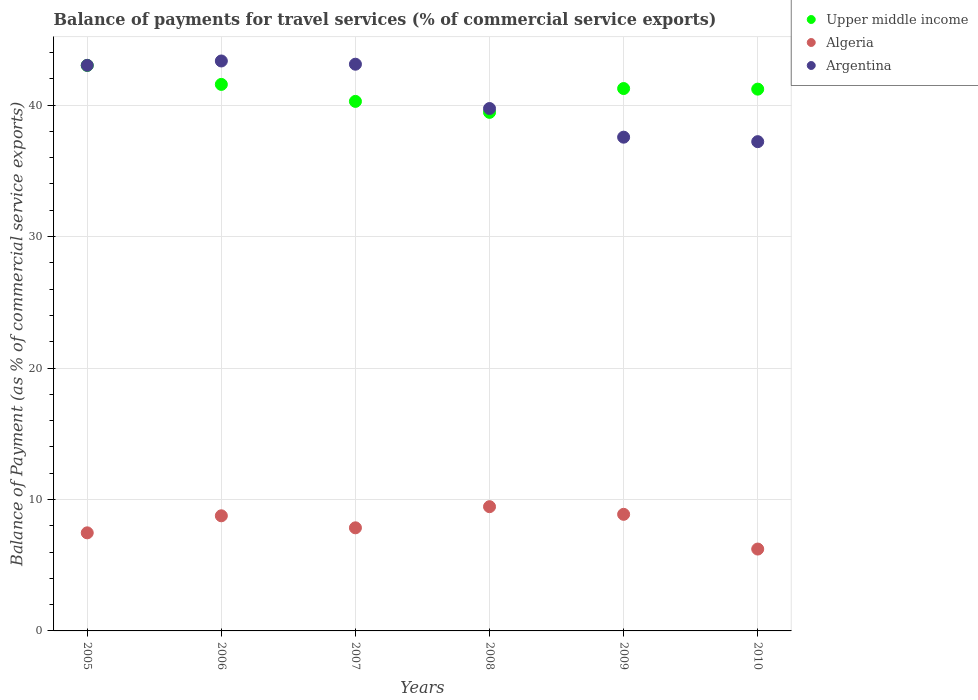How many different coloured dotlines are there?
Offer a terse response. 3. What is the balance of payments for travel services in Argentina in 2007?
Your response must be concise. 43.11. Across all years, what is the maximum balance of payments for travel services in Argentina?
Offer a very short reply. 43.36. Across all years, what is the minimum balance of payments for travel services in Algeria?
Offer a very short reply. 6.23. What is the total balance of payments for travel services in Algeria in the graph?
Provide a succinct answer. 48.61. What is the difference between the balance of payments for travel services in Upper middle income in 2007 and that in 2008?
Keep it short and to the point. 0.84. What is the difference between the balance of payments for travel services in Argentina in 2006 and the balance of payments for travel services in Upper middle income in 2007?
Provide a succinct answer. 3.07. What is the average balance of payments for travel services in Algeria per year?
Provide a succinct answer. 8.1. In the year 2006, what is the difference between the balance of payments for travel services in Upper middle income and balance of payments for travel services in Argentina?
Make the answer very short. -1.78. In how many years, is the balance of payments for travel services in Upper middle income greater than 36 %?
Ensure brevity in your answer.  6. What is the ratio of the balance of payments for travel services in Argentina in 2005 to that in 2007?
Offer a terse response. 1. What is the difference between the highest and the second highest balance of payments for travel services in Upper middle income?
Provide a succinct answer. 1.44. What is the difference between the highest and the lowest balance of payments for travel services in Algeria?
Your answer should be very brief. 3.22. In how many years, is the balance of payments for travel services in Algeria greater than the average balance of payments for travel services in Algeria taken over all years?
Provide a succinct answer. 3. Is it the case that in every year, the sum of the balance of payments for travel services in Algeria and balance of payments for travel services in Upper middle income  is greater than the balance of payments for travel services in Argentina?
Offer a terse response. Yes. Does the balance of payments for travel services in Algeria monotonically increase over the years?
Your response must be concise. No. How many years are there in the graph?
Provide a succinct answer. 6. Where does the legend appear in the graph?
Make the answer very short. Top right. How many legend labels are there?
Keep it short and to the point. 3. How are the legend labels stacked?
Your answer should be compact. Vertical. What is the title of the graph?
Your answer should be compact. Balance of payments for travel services (% of commercial service exports). What is the label or title of the Y-axis?
Offer a terse response. Balance of Payment (as % of commercial service exports). What is the Balance of Payment (as % of commercial service exports) of Upper middle income in 2005?
Make the answer very short. 43.02. What is the Balance of Payment (as % of commercial service exports) of Algeria in 2005?
Your answer should be very brief. 7.46. What is the Balance of Payment (as % of commercial service exports) in Argentina in 2005?
Keep it short and to the point. 43.03. What is the Balance of Payment (as % of commercial service exports) in Upper middle income in 2006?
Offer a very short reply. 41.58. What is the Balance of Payment (as % of commercial service exports) in Algeria in 2006?
Give a very brief answer. 8.76. What is the Balance of Payment (as % of commercial service exports) in Argentina in 2006?
Ensure brevity in your answer.  43.36. What is the Balance of Payment (as % of commercial service exports) of Upper middle income in 2007?
Offer a very short reply. 40.28. What is the Balance of Payment (as % of commercial service exports) of Algeria in 2007?
Provide a short and direct response. 7.84. What is the Balance of Payment (as % of commercial service exports) of Argentina in 2007?
Provide a succinct answer. 43.11. What is the Balance of Payment (as % of commercial service exports) of Upper middle income in 2008?
Provide a short and direct response. 39.45. What is the Balance of Payment (as % of commercial service exports) of Algeria in 2008?
Give a very brief answer. 9.45. What is the Balance of Payment (as % of commercial service exports) in Argentina in 2008?
Make the answer very short. 39.74. What is the Balance of Payment (as % of commercial service exports) of Upper middle income in 2009?
Offer a terse response. 41.26. What is the Balance of Payment (as % of commercial service exports) in Algeria in 2009?
Offer a terse response. 8.87. What is the Balance of Payment (as % of commercial service exports) in Argentina in 2009?
Make the answer very short. 37.56. What is the Balance of Payment (as % of commercial service exports) in Upper middle income in 2010?
Provide a short and direct response. 41.22. What is the Balance of Payment (as % of commercial service exports) in Algeria in 2010?
Offer a terse response. 6.23. What is the Balance of Payment (as % of commercial service exports) in Argentina in 2010?
Ensure brevity in your answer.  37.22. Across all years, what is the maximum Balance of Payment (as % of commercial service exports) in Upper middle income?
Keep it short and to the point. 43.02. Across all years, what is the maximum Balance of Payment (as % of commercial service exports) of Algeria?
Offer a very short reply. 9.45. Across all years, what is the maximum Balance of Payment (as % of commercial service exports) in Argentina?
Provide a succinct answer. 43.36. Across all years, what is the minimum Balance of Payment (as % of commercial service exports) in Upper middle income?
Offer a very short reply. 39.45. Across all years, what is the minimum Balance of Payment (as % of commercial service exports) in Algeria?
Provide a short and direct response. 6.23. Across all years, what is the minimum Balance of Payment (as % of commercial service exports) of Argentina?
Keep it short and to the point. 37.22. What is the total Balance of Payment (as % of commercial service exports) in Upper middle income in the graph?
Provide a succinct answer. 246.81. What is the total Balance of Payment (as % of commercial service exports) in Algeria in the graph?
Your answer should be very brief. 48.61. What is the total Balance of Payment (as % of commercial service exports) of Argentina in the graph?
Offer a very short reply. 244.02. What is the difference between the Balance of Payment (as % of commercial service exports) of Upper middle income in 2005 and that in 2006?
Give a very brief answer. 1.44. What is the difference between the Balance of Payment (as % of commercial service exports) of Algeria in 2005 and that in 2006?
Ensure brevity in your answer.  -1.3. What is the difference between the Balance of Payment (as % of commercial service exports) in Argentina in 2005 and that in 2006?
Keep it short and to the point. -0.33. What is the difference between the Balance of Payment (as % of commercial service exports) of Upper middle income in 2005 and that in 2007?
Offer a very short reply. 2.74. What is the difference between the Balance of Payment (as % of commercial service exports) in Algeria in 2005 and that in 2007?
Ensure brevity in your answer.  -0.38. What is the difference between the Balance of Payment (as % of commercial service exports) in Argentina in 2005 and that in 2007?
Give a very brief answer. -0.09. What is the difference between the Balance of Payment (as % of commercial service exports) of Upper middle income in 2005 and that in 2008?
Your answer should be compact. 3.57. What is the difference between the Balance of Payment (as % of commercial service exports) of Algeria in 2005 and that in 2008?
Provide a short and direct response. -1.99. What is the difference between the Balance of Payment (as % of commercial service exports) of Argentina in 2005 and that in 2008?
Your response must be concise. 3.28. What is the difference between the Balance of Payment (as % of commercial service exports) of Upper middle income in 2005 and that in 2009?
Provide a short and direct response. 1.76. What is the difference between the Balance of Payment (as % of commercial service exports) in Algeria in 2005 and that in 2009?
Offer a terse response. -1.41. What is the difference between the Balance of Payment (as % of commercial service exports) of Argentina in 2005 and that in 2009?
Your answer should be very brief. 5.46. What is the difference between the Balance of Payment (as % of commercial service exports) of Upper middle income in 2005 and that in 2010?
Offer a terse response. 1.8. What is the difference between the Balance of Payment (as % of commercial service exports) in Algeria in 2005 and that in 2010?
Ensure brevity in your answer.  1.23. What is the difference between the Balance of Payment (as % of commercial service exports) in Argentina in 2005 and that in 2010?
Your response must be concise. 5.81. What is the difference between the Balance of Payment (as % of commercial service exports) of Upper middle income in 2006 and that in 2007?
Keep it short and to the point. 1.29. What is the difference between the Balance of Payment (as % of commercial service exports) of Algeria in 2006 and that in 2007?
Keep it short and to the point. 0.91. What is the difference between the Balance of Payment (as % of commercial service exports) of Argentina in 2006 and that in 2007?
Provide a short and direct response. 0.25. What is the difference between the Balance of Payment (as % of commercial service exports) in Upper middle income in 2006 and that in 2008?
Your response must be concise. 2.13. What is the difference between the Balance of Payment (as % of commercial service exports) of Algeria in 2006 and that in 2008?
Make the answer very short. -0.69. What is the difference between the Balance of Payment (as % of commercial service exports) of Argentina in 2006 and that in 2008?
Provide a short and direct response. 3.62. What is the difference between the Balance of Payment (as % of commercial service exports) in Upper middle income in 2006 and that in 2009?
Provide a succinct answer. 0.31. What is the difference between the Balance of Payment (as % of commercial service exports) of Algeria in 2006 and that in 2009?
Your response must be concise. -0.11. What is the difference between the Balance of Payment (as % of commercial service exports) of Argentina in 2006 and that in 2009?
Ensure brevity in your answer.  5.8. What is the difference between the Balance of Payment (as % of commercial service exports) of Upper middle income in 2006 and that in 2010?
Your answer should be compact. 0.36. What is the difference between the Balance of Payment (as % of commercial service exports) of Algeria in 2006 and that in 2010?
Provide a succinct answer. 2.53. What is the difference between the Balance of Payment (as % of commercial service exports) in Argentina in 2006 and that in 2010?
Offer a very short reply. 6.14. What is the difference between the Balance of Payment (as % of commercial service exports) in Upper middle income in 2007 and that in 2008?
Ensure brevity in your answer.  0.84. What is the difference between the Balance of Payment (as % of commercial service exports) of Algeria in 2007 and that in 2008?
Ensure brevity in your answer.  -1.61. What is the difference between the Balance of Payment (as % of commercial service exports) in Argentina in 2007 and that in 2008?
Keep it short and to the point. 3.37. What is the difference between the Balance of Payment (as % of commercial service exports) in Upper middle income in 2007 and that in 2009?
Give a very brief answer. -0.98. What is the difference between the Balance of Payment (as % of commercial service exports) of Algeria in 2007 and that in 2009?
Offer a terse response. -1.03. What is the difference between the Balance of Payment (as % of commercial service exports) of Argentina in 2007 and that in 2009?
Provide a succinct answer. 5.55. What is the difference between the Balance of Payment (as % of commercial service exports) in Upper middle income in 2007 and that in 2010?
Make the answer very short. -0.93. What is the difference between the Balance of Payment (as % of commercial service exports) in Algeria in 2007 and that in 2010?
Keep it short and to the point. 1.62. What is the difference between the Balance of Payment (as % of commercial service exports) of Argentina in 2007 and that in 2010?
Offer a terse response. 5.89. What is the difference between the Balance of Payment (as % of commercial service exports) in Upper middle income in 2008 and that in 2009?
Ensure brevity in your answer.  -1.81. What is the difference between the Balance of Payment (as % of commercial service exports) of Algeria in 2008 and that in 2009?
Offer a very short reply. 0.58. What is the difference between the Balance of Payment (as % of commercial service exports) in Argentina in 2008 and that in 2009?
Provide a short and direct response. 2.18. What is the difference between the Balance of Payment (as % of commercial service exports) in Upper middle income in 2008 and that in 2010?
Offer a very short reply. -1.77. What is the difference between the Balance of Payment (as % of commercial service exports) of Algeria in 2008 and that in 2010?
Your response must be concise. 3.22. What is the difference between the Balance of Payment (as % of commercial service exports) of Argentina in 2008 and that in 2010?
Offer a very short reply. 2.52. What is the difference between the Balance of Payment (as % of commercial service exports) in Upper middle income in 2009 and that in 2010?
Your answer should be very brief. 0.05. What is the difference between the Balance of Payment (as % of commercial service exports) in Algeria in 2009 and that in 2010?
Give a very brief answer. 2.64. What is the difference between the Balance of Payment (as % of commercial service exports) of Argentina in 2009 and that in 2010?
Offer a terse response. 0.34. What is the difference between the Balance of Payment (as % of commercial service exports) of Upper middle income in 2005 and the Balance of Payment (as % of commercial service exports) of Algeria in 2006?
Offer a very short reply. 34.26. What is the difference between the Balance of Payment (as % of commercial service exports) in Upper middle income in 2005 and the Balance of Payment (as % of commercial service exports) in Argentina in 2006?
Your answer should be very brief. -0.34. What is the difference between the Balance of Payment (as % of commercial service exports) in Algeria in 2005 and the Balance of Payment (as % of commercial service exports) in Argentina in 2006?
Ensure brevity in your answer.  -35.9. What is the difference between the Balance of Payment (as % of commercial service exports) in Upper middle income in 2005 and the Balance of Payment (as % of commercial service exports) in Algeria in 2007?
Offer a very short reply. 35.18. What is the difference between the Balance of Payment (as % of commercial service exports) of Upper middle income in 2005 and the Balance of Payment (as % of commercial service exports) of Argentina in 2007?
Provide a short and direct response. -0.09. What is the difference between the Balance of Payment (as % of commercial service exports) of Algeria in 2005 and the Balance of Payment (as % of commercial service exports) of Argentina in 2007?
Your response must be concise. -35.65. What is the difference between the Balance of Payment (as % of commercial service exports) of Upper middle income in 2005 and the Balance of Payment (as % of commercial service exports) of Algeria in 2008?
Your answer should be compact. 33.57. What is the difference between the Balance of Payment (as % of commercial service exports) in Upper middle income in 2005 and the Balance of Payment (as % of commercial service exports) in Argentina in 2008?
Your answer should be very brief. 3.28. What is the difference between the Balance of Payment (as % of commercial service exports) of Algeria in 2005 and the Balance of Payment (as % of commercial service exports) of Argentina in 2008?
Your response must be concise. -32.28. What is the difference between the Balance of Payment (as % of commercial service exports) of Upper middle income in 2005 and the Balance of Payment (as % of commercial service exports) of Algeria in 2009?
Make the answer very short. 34.15. What is the difference between the Balance of Payment (as % of commercial service exports) in Upper middle income in 2005 and the Balance of Payment (as % of commercial service exports) in Argentina in 2009?
Offer a terse response. 5.46. What is the difference between the Balance of Payment (as % of commercial service exports) of Algeria in 2005 and the Balance of Payment (as % of commercial service exports) of Argentina in 2009?
Your answer should be compact. -30.1. What is the difference between the Balance of Payment (as % of commercial service exports) of Upper middle income in 2005 and the Balance of Payment (as % of commercial service exports) of Algeria in 2010?
Give a very brief answer. 36.79. What is the difference between the Balance of Payment (as % of commercial service exports) of Upper middle income in 2005 and the Balance of Payment (as % of commercial service exports) of Argentina in 2010?
Give a very brief answer. 5.8. What is the difference between the Balance of Payment (as % of commercial service exports) of Algeria in 2005 and the Balance of Payment (as % of commercial service exports) of Argentina in 2010?
Offer a terse response. -29.76. What is the difference between the Balance of Payment (as % of commercial service exports) of Upper middle income in 2006 and the Balance of Payment (as % of commercial service exports) of Algeria in 2007?
Your answer should be compact. 33.73. What is the difference between the Balance of Payment (as % of commercial service exports) in Upper middle income in 2006 and the Balance of Payment (as % of commercial service exports) in Argentina in 2007?
Your response must be concise. -1.54. What is the difference between the Balance of Payment (as % of commercial service exports) in Algeria in 2006 and the Balance of Payment (as % of commercial service exports) in Argentina in 2007?
Provide a short and direct response. -34.35. What is the difference between the Balance of Payment (as % of commercial service exports) in Upper middle income in 2006 and the Balance of Payment (as % of commercial service exports) in Algeria in 2008?
Make the answer very short. 32.12. What is the difference between the Balance of Payment (as % of commercial service exports) in Upper middle income in 2006 and the Balance of Payment (as % of commercial service exports) in Argentina in 2008?
Ensure brevity in your answer.  1.83. What is the difference between the Balance of Payment (as % of commercial service exports) in Algeria in 2006 and the Balance of Payment (as % of commercial service exports) in Argentina in 2008?
Provide a short and direct response. -30.98. What is the difference between the Balance of Payment (as % of commercial service exports) in Upper middle income in 2006 and the Balance of Payment (as % of commercial service exports) in Algeria in 2009?
Offer a terse response. 32.71. What is the difference between the Balance of Payment (as % of commercial service exports) of Upper middle income in 2006 and the Balance of Payment (as % of commercial service exports) of Argentina in 2009?
Give a very brief answer. 4.01. What is the difference between the Balance of Payment (as % of commercial service exports) of Algeria in 2006 and the Balance of Payment (as % of commercial service exports) of Argentina in 2009?
Offer a terse response. -28.8. What is the difference between the Balance of Payment (as % of commercial service exports) in Upper middle income in 2006 and the Balance of Payment (as % of commercial service exports) in Algeria in 2010?
Make the answer very short. 35.35. What is the difference between the Balance of Payment (as % of commercial service exports) of Upper middle income in 2006 and the Balance of Payment (as % of commercial service exports) of Argentina in 2010?
Offer a very short reply. 4.36. What is the difference between the Balance of Payment (as % of commercial service exports) of Algeria in 2006 and the Balance of Payment (as % of commercial service exports) of Argentina in 2010?
Your answer should be compact. -28.46. What is the difference between the Balance of Payment (as % of commercial service exports) of Upper middle income in 2007 and the Balance of Payment (as % of commercial service exports) of Algeria in 2008?
Your answer should be compact. 30.83. What is the difference between the Balance of Payment (as % of commercial service exports) in Upper middle income in 2007 and the Balance of Payment (as % of commercial service exports) in Argentina in 2008?
Provide a succinct answer. 0.54. What is the difference between the Balance of Payment (as % of commercial service exports) of Algeria in 2007 and the Balance of Payment (as % of commercial service exports) of Argentina in 2008?
Your response must be concise. -31.9. What is the difference between the Balance of Payment (as % of commercial service exports) in Upper middle income in 2007 and the Balance of Payment (as % of commercial service exports) in Algeria in 2009?
Offer a terse response. 31.41. What is the difference between the Balance of Payment (as % of commercial service exports) of Upper middle income in 2007 and the Balance of Payment (as % of commercial service exports) of Argentina in 2009?
Your answer should be very brief. 2.72. What is the difference between the Balance of Payment (as % of commercial service exports) of Algeria in 2007 and the Balance of Payment (as % of commercial service exports) of Argentina in 2009?
Provide a short and direct response. -29.72. What is the difference between the Balance of Payment (as % of commercial service exports) in Upper middle income in 2007 and the Balance of Payment (as % of commercial service exports) in Algeria in 2010?
Provide a succinct answer. 34.06. What is the difference between the Balance of Payment (as % of commercial service exports) of Upper middle income in 2007 and the Balance of Payment (as % of commercial service exports) of Argentina in 2010?
Offer a terse response. 3.06. What is the difference between the Balance of Payment (as % of commercial service exports) in Algeria in 2007 and the Balance of Payment (as % of commercial service exports) in Argentina in 2010?
Provide a short and direct response. -29.38. What is the difference between the Balance of Payment (as % of commercial service exports) of Upper middle income in 2008 and the Balance of Payment (as % of commercial service exports) of Algeria in 2009?
Give a very brief answer. 30.58. What is the difference between the Balance of Payment (as % of commercial service exports) of Upper middle income in 2008 and the Balance of Payment (as % of commercial service exports) of Argentina in 2009?
Give a very brief answer. 1.89. What is the difference between the Balance of Payment (as % of commercial service exports) of Algeria in 2008 and the Balance of Payment (as % of commercial service exports) of Argentina in 2009?
Make the answer very short. -28.11. What is the difference between the Balance of Payment (as % of commercial service exports) in Upper middle income in 2008 and the Balance of Payment (as % of commercial service exports) in Algeria in 2010?
Your response must be concise. 33.22. What is the difference between the Balance of Payment (as % of commercial service exports) of Upper middle income in 2008 and the Balance of Payment (as % of commercial service exports) of Argentina in 2010?
Offer a very short reply. 2.23. What is the difference between the Balance of Payment (as % of commercial service exports) in Algeria in 2008 and the Balance of Payment (as % of commercial service exports) in Argentina in 2010?
Your answer should be compact. -27.77. What is the difference between the Balance of Payment (as % of commercial service exports) in Upper middle income in 2009 and the Balance of Payment (as % of commercial service exports) in Algeria in 2010?
Make the answer very short. 35.03. What is the difference between the Balance of Payment (as % of commercial service exports) of Upper middle income in 2009 and the Balance of Payment (as % of commercial service exports) of Argentina in 2010?
Your answer should be very brief. 4.04. What is the difference between the Balance of Payment (as % of commercial service exports) of Algeria in 2009 and the Balance of Payment (as % of commercial service exports) of Argentina in 2010?
Your response must be concise. -28.35. What is the average Balance of Payment (as % of commercial service exports) in Upper middle income per year?
Make the answer very short. 41.13. What is the average Balance of Payment (as % of commercial service exports) of Algeria per year?
Provide a short and direct response. 8.1. What is the average Balance of Payment (as % of commercial service exports) of Argentina per year?
Make the answer very short. 40.67. In the year 2005, what is the difference between the Balance of Payment (as % of commercial service exports) in Upper middle income and Balance of Payment (as % of commercial service exports) in Algeria?
Your response must be concise. 35.56. In the year 2005, what is the difference between the Balance of Payment (as % of commercial service exports) in Upper middle income and Balance of Payment (as % of commercial service exports) in Argentina?
Offer a terse response. -0.01. In the year 2005, what is the difference between the Balance of Payment (as % of commercial service exports) of Algeria and Balance of Payment (as % of commercial service exports) of Argentina?
Your answer should be compact. -35.56. In the year 2006, what is the difference between the Balance of Payment (as % of commercial service exports) in Upper middle income and Balance of Payment (as % of commercial service exports) in Algeria?
Give a very brief answer. 32.82. In the year 2006, what is the difference between the Balance of Payment (as % of commercial service exports) of Upper middle income and Balance of Payment (as % of commercial service exports) of Argentina?
Provide a short and direct response. -1.78. In the year 2006, what is the difference between the Balance of Payment (as % of commercial service exports) in Algeria and Balance of Payment (as % of commercial service exports) in Argentina?
Ensure brevity in your answer.  -34.6. In the year 2007, what is the difference between the Balance of Payment (as % of commercial service exports) of Upper middle income and Balance of Payment (as % of commercial service exports) of Algeria?
Provide a succinct answer. 32.44. In the year 2007, what is the difference between the Balance of Payment (as % of commercial service exports) in Upper middle income and Balance of Payment (as % of commercial service exports) in Argentina?
Give a very brief answer. -2.83. In the year 2007, what is the difference between the Balance of Payment (as % of commercial service exports) of Algeria and Balance of Payment (as % of commercial service exports) of Argentina?
Provide a short and direct response. -35.27. In the year 2008, what is the difference between the Balance of Payment (as % of commercial service exports) in Upper middle income and Balance of Payment (as % of commercial service exports) in Algeria?
Your answer should be compact. 30. In the year 2008, what is the difference between the Balance of Payment (as % of commercial service exports) of Upper middle income and Balance of Payment (as % of commercial service exports) of Argentina?
Make the answer very short. -0.29. In the year 2008, what is the difference between the Balance of Payment (as % of commercial service exports) in Algeria and Balance of Payment (as % of commercial service exports) in Argentina?
Your answer should be very brief. -30.29. In the year 2009, what is the difference between the Balance of Payment (as % of commercial service exports) of Upper middle income and Balance of Payment (as % of commercial service exports) of Algeria?
Your answer should be compact. 32.39. In the year 2009, what is the difference between the Balance of Payment (as % of commercial service exports) of Upper middle income and Balance of Payment (as % of commercial service exports) of Argentina?
Provide a short and direct response. 3.7. In the year 2009, what is the difference between the Balance of Payment (as % of commercial service exports) of Algeria and Balance of Payment (as % of commercial service exports) of Argentina?
Provide a short and direct response. -28.69. In the year 2010, what is the difference between the Balance of Payment (as % of commercial service exports) of Upper middle income and Balance of Payment (as % of commercial service exports) of Algeria?
Offer a terse response. 34.99. In the year 2010, what is the difference between the Balance of Payment (as % of commercial service exports) of Upper middle income and Balance of Payment (as % of commercial service exports) of Argentina?
Offer a terse response. 4. In the year 2010, what is the difference between the Balance of Payment (as % of commercial service exports) in Algeria and Balance of Payment (as % of commercial service exports) in Argentina?
Provide a short and direct response. -30.99. What is the ratio of the Balance of Payment (as % of commercial service exports) of Upper middle income in 2005 to that in 2006?
Provide a short and direct response. 1.03. What is the ratio of the Balance of Payment (as % of commercial service exports) in Algeria in 2005 to that in 2006?
Provide a succinct answer. 0.85. What is the ratio of the Balance of Payment (as % of commercial service exports) of Upper middle income in 2005 to that in 2007?
Offer a very short reply. 1.07. What is the ratio of the Balance of Payment (as % of commercial service exports) in Algeria in 2005 to that in 2007?
Your answer should be compact. 0.95. What is the ratio of the Balance of Payment (as % of commercial service exports) of Upper middle income in 2005 to that in 2008?
Give a very brief answer. 1.09. What is the ratio of the Balance of Payment (as % of commercial service exports) of Algeria in 2005 to that in 2008?
Your answer should be compact. 0.79. What is the ratio of the Balance of Payment (as % of commercial service exports) in Argentina in 2005 to that in 2008?
Give a very brief answer. 1.08. What is the ratio of the Balance of Payment (as % of commercial service exports) of Upper middle income in 2005 to that in 2009?
Your answer should be very brief. 1.04. What is the ratio of the Balance of Payment (as % of commercial service exports) of Algeria in 2005 to that in 2009?
Provide a short and direct response. 0.84. What is the ratio of the Balance of Payment (as % of commercial service exports) of Argentina in 2005 to that in 2009?
Your answer should be compact. 1.15. What is the ratio of the Balance of Payment (as % of commercial service exports) in Upper middle income in 2005 to that in 2010?
Offer a very short reply. 1.04. What is the ratio of the Balance of Payment (as % of commercial service exports) of Algeria in 2005 to that in 2010?
Provide a short and direct response. 1.2. What is the ratio of the Balance of Payment (as % of commercial service exports) of Argentina in 2005 to that in 2010?
Provide a short and direct response. 1.16. What is the ratio of the Balance of Payment (as % of commercial service exports) of Upper middle income in 2006 to that in 2007?
Your response must be concise. 1.03. What is the ratio of the Balance of Payment (as % of commercial service exports) in Algeria in 2006 to that in 2007?
Provide a succinct answer. 1.12. What is the ratio of the Balance of Payment (as % of commercial service exports) of Upper middle income in 2006 to that in 2008?
Offer a terse response. 1.05. What is the ratio of the Balance of Payment (as % of commercial service exports) of Algeria in 2006 to that in 2008?
Offer a terse response. 0.93. What is the ratio of the Balance of Payment (as % of commercial service exports) of Argentina in 2006 to that in 2008?
Ensure brevity in your answer.  1.09. What is the ratio of the Balance of Payment (as % of commercial service exports) in Upper middle income in 2006 to that in 2009?
Your response must be concise. 1.01. What is the ratio of the Balance of Payment (as % of commercial service exports) in Algeria in 2006 to that in 2009?
Your response must be concise. 0.99. What is the ratio of the Balance of Payment (as % of commercial service exports) in Argentina in 2006 to that in 2009?
Ensure brevity in your answer.  1.15. What is the ratio of the Balance of Payment (as % of commercial service exports) of Upper middle income in 2006 to that in 2010?
Make the answer very short. 1.01. What is the ratio of the Balance of Payment (as % of commercial service exports) in Algeria in 2006 to that in 2010?
Your response must be concise. 1.41. What is the ratio of the Balance of Payment (as % of commercial service exports) in Argentina in 2006 to that in 2010?
Provide a succinct answer. 1.16. What is the ratio of the Balance of Payment (as % of commercial service exports) of Upper middle income in 2007 to that in 2008?
Keep it short and to the point. 1.02. What is the ratio of the Balance of Payment (as % of commercial service exports) in Algeria in 2007 to that in 2008?
Your answer should be very brief. 0.83. What is the ratio of the Balance of Payment (as % of commercial service exports) of Argentina in 2007 to that in 2008?
Make the answer very short. 1.08. What is the ratio of the Balance of Payment (as % of commercial service exports) of Upper middle income in 2007 to that in 2009?
Keep it short and to the point. 0.98. What is the ratio of the Balance of Payment (as % of commercial service exports) in Algeria in 2007 to that in 2009?
Provide a short and direct response. 0.88. What is the ratio of the Balance of Payment (as % of commercial service exports) of Argentina in 2007 to that in 2009?
Give a very brief answer. 1.15. What is the ratio of the Balance of Payment (as % of commercial service exports) of Upper middle income in 2007 to that in 2010?
Give a very brief answer. 0.98. What is the ratio of the Balance of Payment (as % of commercial service exports) of Algeria in 2007 to that in 2010?
Provide a short and direct response. 1.26. What is the ratio of the Balance of Payment (as % of commercial service exports) in Argentina in 2007 to that in 2010?
Offer a very short reply. 1.16. What is the ratio of the Balance of Payment (as % of commercial service exports) of Upper middle income in 2008 to that in 2009?
Your answer should be very brief. 0.96. What is the ratio of the Balance of Payment (as % of commercial service exports) in Algeria in 2008 to that in 2009?
Offer a very short reply. 1.07. What is the ratio of the Balance of Payment (as % of commercial service exports) of Argentina in 2008 to that in 2009?
Provide a short and direct response. 1.06. What is the ratio of the Balance of Payment (as % of commercial service exports) in Upper middle income in 2008 to that in 2010?
Offer a terse response. 0.96. What is the ratio of the Balance of Payment (as % of commercial service exports) of Algeria in 2008 to that in 2010?
Your answer should be very brief. 1.52. What is the ratio of the Balance of Payment (as % of commercial service exports) in Argentina in 2008 to that in 2010?
Your response must be concise. 1.07. What is the ratio of the Balance of Payment (as % of commercial service exports) of Algeria in 2009 to that in 2010?
Give a very brief answer. 1.42. What is the ratio of the Balance of Payment (as % of commercial service exports) in Argentina in 2009 to that in 2010?
Your answer should be very brief. 1.01. What is the difference between the highest and the second highest Balance of Payment (as % of commercial service exports) of Upper middle income?
Keep it short and to the point. 1.44. What is the difference between the highest and the second highest Balance of Payment (as % of commercial service exports) in Algeria?
Offer a terse response. 0.58. What is the difference between the highest and the second highest Balance of Payment (as % of commercial service exports) of Argentina?
Give a very brief answer. 0.25. What is the difference between the highest and the lowest Balance of Payment (as % of commercial service exports) of Upper middle income?
Your answer should be very brief. 3.57. What is the difference between the highest and the lowest Balance of Payment (as % of commercial service exports) in Algeria?
Offer a very short reply. 3.22. What is the difference between the highest and the lowest Balance of Payment (as % of commercial service exports) in Argentina?
Your answer should be very brief. 6.14. 